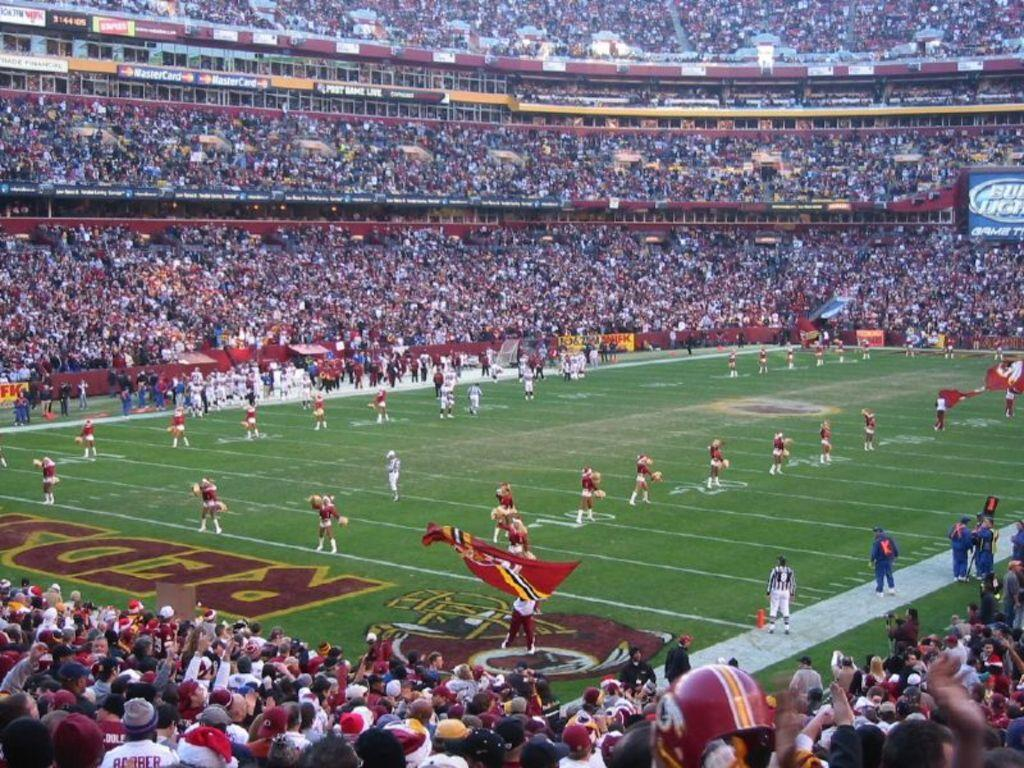What type of structure is shown in the image? The image depicts a stadium. Can you describe the people in the image? There are people on the ground, and one person is holding a flag. How many people can be seen in the image? There are many people visible from left to right. What is located on the right side of the image? There is a board on the right side of the image. What type of vegetable is being used as a headrest for the person holding the flag? There is no vegetable present in the image, and no one is using a vegetable as a headrest. 